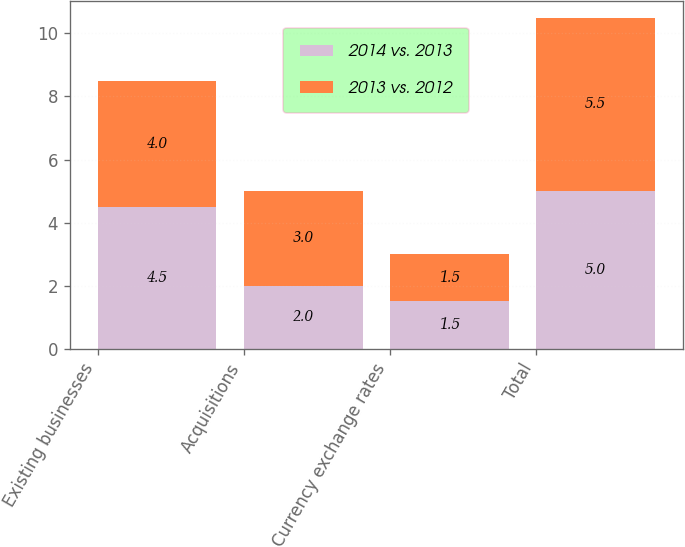Convert chart to OTSL. <chart><loc_0><loc_0><loc_500><loc_500><stacked_bar_chart><ecel><fcel>Existing businesses<fcel>Acquisitions<fcel>Currency exchange rates<fcel>Total<nl><fcel>2014 vs. 2013<fcel>4.5<fcel>2<fcel>1.5<fcel>5<nl><fcel>2013 vs. 2012<fcel>4<fcel>3<fcel>1.5<fcel>5.5<nl></chart> 